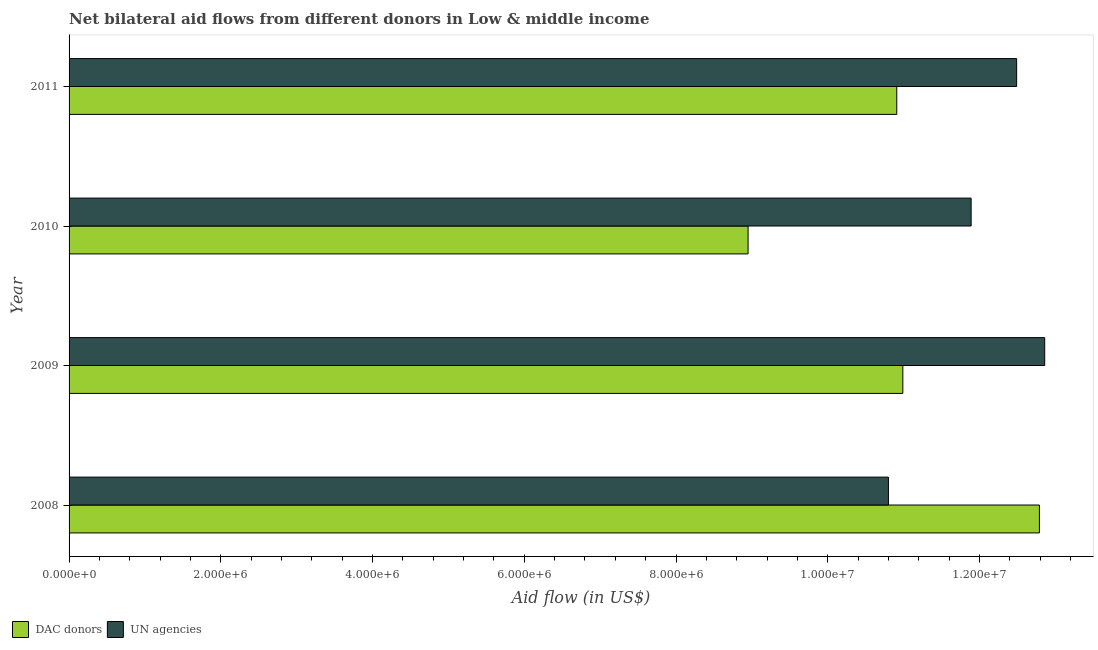How many different coloured bars are there?
Give a very brief answer. 2. How many groups of bars are there?
Your answer should be very brief. 4. How many bars are there on the 3rd tick from the top?
Your answer should be compact. 2. What is the aid flow from un agencies in 2009?
Ensure brevity in your answer.  1.29e+07. Across all years, what is the maximum aid flow from un agencies?
Your answer should be very brief. 1.29e+07. Across all years, what is the minimum aid flow from un agencies?
Your response must be concise. 1.08e+07. In which year was the aid flow from un agencies minimum?
Make the answer very short. 2008. What is the total aid flow from dac donors in the graph?
Keep it short and to the point. 4.36e+07. What is the difference between the aid flow from un agencies in 2008 and that in 2010?
Provide a succinct answer. -1.09e+06. What is the difference between the aid flow from dac donors in 2008 and the aid flow from un agencies in 2010?
Make the answer very short. 9.00e+05. What is the average aid flow from dac donors per year?
Offer a terse response. 1.09e+07. In the year 2009, what is the difference between the aid flow from un agencies and aid flow from dac donors?
Provide a short and direct response. 1.87e+06. What is the ratio of the aid flow from dac donors in 2010 to that in 2011?
Your answer should be very brief. 0.82. What is the difference between the highest and the lowest aid flow from dac donors?
Provide a succinct answer. 3.84e+06. In how many years, is the aid flow from un agencies greater than the average aid flow from un agencies taken over all years?
Provide a short and direct response. 2. Is the sum of the aid flow from dac donors in 2010 and 2011 greater than the maximum aid flow from un agencies across all years?
Make the answer very short. Yes. What does the 2nd bar from the top in 2010 represents?
Provide a succinct answer. DAC donors. What does the 1st bar from the bottom in 2008 represents?
Provide a short and direct response. DAC donors. How many bars are there?
Make the answer very short. 8. Are all the bars in the graph horizontal?
Your answer should be very brief. Yes. How many years are there in the graph?
Keep it short and to the point. 4. Does the graph contain any zero values?
Keep it short and to the point. No. Does the graph contain grids?
Give a very brief answer. No. Where does the legend appear in the graph?
Keep it short and to the point. Bottom left. How many legend labels are there?
Provide a succinct answer. 2. How are the legend labels stacked?
Give a very brief answer. Horizontal. What is the title of the graph?
Keep it short and to the point. Net bilateral aid flows from different donors in Low & middle income. What is the label or title of the X-axis?
Provide a succinct answer. Aid flow (in US$). What is the Aid flow (in US$) of DAC donors in 2008?
Give a very brief answer. 1.28e+07. What is the Aid flow (in US$) of UN agencies in 2008?
Keep it short and to the point. 1.08e+07. What is the Aid flow (in US$) of DAC donors in 2009?
Your answer should be compact. 1.10e+07. What is the Aid flow (in US$) of UN agencies in 2009?
Keep it short and to the point. 1.29e+07. What is the Aid flow (in US$) of DAC donors in 2010?
Keep it short and to the point. 8.95e+06. What is the Aid flow (in US$) in UN agencies in 2010?
Offer a terse response. 1.19e+07. What is the Aid flow (in US$) in DAC donors in 2011?
Your response must be concise. 1.09e+07. What is the Aid flow (in US$) in UN agencies in 2011?
Ensure brevity in your answer.  1.25e+07. Across all years, what is the maximum Aid flow (in US$) of DAC donors?
Ensure brevity in your answer.  1.28e+07. Across all years, what is the maximum Aid flow (in US$) in UN agencies?
Make the answer very short. 1.29e+07. Across all years, what is the minimum Aid flow (in US$) in DAC donors?
Your response must be concise. 8.95e+06. Across all years, what is the minimum Aid flow (in US$) in UN agencies?
Your answer should be compact. 1.08e+07. What is the total Aid flow (in US$) of DAC donors in the graph?
Provide a short and direct response. 4.36e+07. What is the total Aid flow (in US$) in UN agencies in the graph?
Provide a succinct answer. 4.80e+07. What is the difference between the Aid flow (in US$) of DAC donors in 2008 and that in 2009?
Your answer should be compact. 1.80e+06. What is the difference between the Aid flow (in US$) of UN agencies in 2008 and that in 2009?
Keep it short and to the point. -2.06e+06. What is the difference between the Aid flow (in US$) in DAC donors in 2008 and that in 2010?
Offer a terse response. 3.84e+06. What is the difference between the Aid flow (in US$) of UN agencies in 2008 and that in 2010?
Keep it short and to the point. -1.09e+06. What is the difference between the Aid flow (in US$) in DAC donors in 2008 and that in 2011?
Your response must be concise. 1.88e+06. What is the difference between the Aid flow (in US$) of UN agencies in 2008 and that in 2011?
Offer a very short reply. -1.69e+06. What is the difference between the Aid flow (in US$) of DAC donors in 2009 and that in 2010?
Your answer should be very brief. 2.04e+06. What is the difference between the Aid flow (in US$) of UN agencies in 2009 and that in 2010?
Provide a short and direct response. 9.70e+05. What is the difference between the Aid flow (in US$) of UN agencies in 2009 and that in 2011?
Make the answer very short. 3.70e+05. What is the difference between the Aid flow (in US$) of DAC donors in 2010 and that in 2011?
Ensure brevity in your answer.  -1.96e+06. What is the difference between the Aid flow (in US$) of UN agencies in 2010 and that in 2011?
Make the answer very short. -6.00e+05. What is the difference between the Aid flow (in US$) of DAC donors in 2008 and the Aid flow (in US$) of UN agencies in 2009?
Give a very brief answer. -7.00e+04. What is the difference between the Aid flow (in US$) of DAC donors in 2008 and the Aid flow (in US$) of UN agencies in 2010?
Your response must be concise. 9.00e+05. What is the difference between the Aid flow (in US$) in DAC donors in 2008 and the Aid flow (in US$) in UN agencies in 2011?
Provide a short and direct response. 3.00e+05. What is the difference between the Aid flow (in US$) in DAC donors in 2009 and the Aid flow (in US$) in UN agencies in 2010?
Your answer should be very brief. -9.00e+05. What is the difference between the Aid flow (in US$) in DAC donors in 2009 and the Aid flow (in US$) in UN agencies in 2011?
Provide a succinct answer. -1.50e+06. What is the difference between the Aid flow (in US$) of DAC donors in 2010 and the Aid flow (in US$) of UN agencies in 2011?
Your answer should be compact. -3.54e+06. What is the average Aid flow (in US$) of DAC donors per year?
Your response must be concise. 1.09e+07. What is the average Aid flow (in US$) in UN agencies per year?
Offer a very short reply. 1.20e+07. In the year 2008, what is the difference between the Aid flow (in US$) in DAC donors and Aid flow (in US$) in UN agencies?
Offer a terse response. 1.99e+06. In the year 2009, what is the difference between the Aid flow (in US$) of DAC donors and Aid flow (in US$) of UN agencies?
Ensure brevity in your answer.  -1.87e+06. In the year 2010, what is the difference between the Aid flow (in US$) in DAC donors and Aid flow (in US$) in UN agencies?
Offer a terse response. -2.94e+06. In the year 2011, what is the difference between the Aid flow (in US$) of DAC donors and Aid flow (in US$) of UN agencies?
Keep it short and to the point. -1.58e+06. What is the ratio of the Aid flow (in US$) of DAC donors in 2008 to that in 2009?
Your answer should be compact. 1.16. What is the ratio of the Aid flow (in US$) in UN agencies in 2008 to that in 2009?
Your answer should be compact. 0.84. What is the ratio of the Aid flow (in US$) in DAC donors in 2008 to that in 2010?
Your answer should be compact. 1.43. What is the ratio of the Aid flow (in US$) in UN agencies in 2008 to that in 2010?
Your answer should be very brief. 0.91. What is the ratio of the Aid flow (in US$) of DAC donors in 2008 to that in 2011?
Your response must be concise. 1.17. What is the ratio of the Aid flow (in US$) in UN agencies in 2008 to that in 2011?
Offer a terse response. 0.86. What is the ratio of the Aid flow (in US$) in DAC donors in 2009 to that in 2010?
Keep it short and to the point. 1.23. What is the ratio of the Aid flow (in US$) of UN agencies in 2009 to that in 2010?
Offer a terse response. 1.08. What is the ratio of the Aid flow (in US$) in DAC donors in 2009 to that in 2011?
Your response must be concise. 1.01. What is the ratio of the Aid flow (in US$) of UN agencies in 2009 to that in 2011?
Give a very brief answer. 1.03. What is the ratio of the Aid flow (in US$) of DAC donors in 2010 to that in 2011?
Ensure brevity in your answer.  0.82. What is the ratio of the Aid flow (in US$) in UN agencies in 2010 to that in 2011?
Keep it short and to the point. 0.95. What is the difference between the highest and the second highest Aid flow (in US$) of DAC donors?
Offer a very short reply. 1.80e+06. What is the difference between the highest and the second highest Aid flow (in US$) in UN agencies?
Your response must be concise. 3.70e+05. What is the difference between the highest and the lowest Aid flow (in US$) in DAC donors?
Your answer should be very brief. 3.84e+06. What is the difference between the highest and the lowest Aid flow (in US$) of UN agencies?
Make the answer very short. 2.06e+06. 